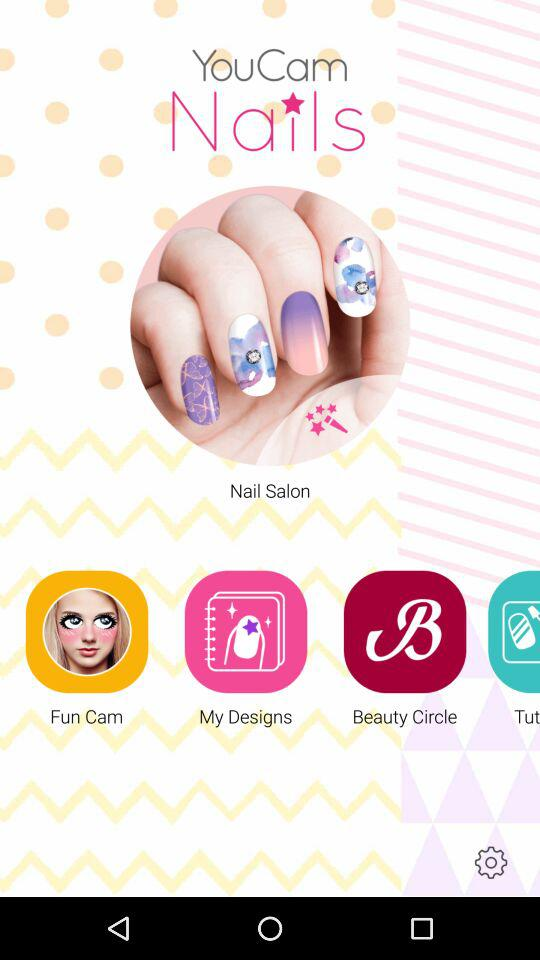What is the application name? The application name is "YouCam Nails". 